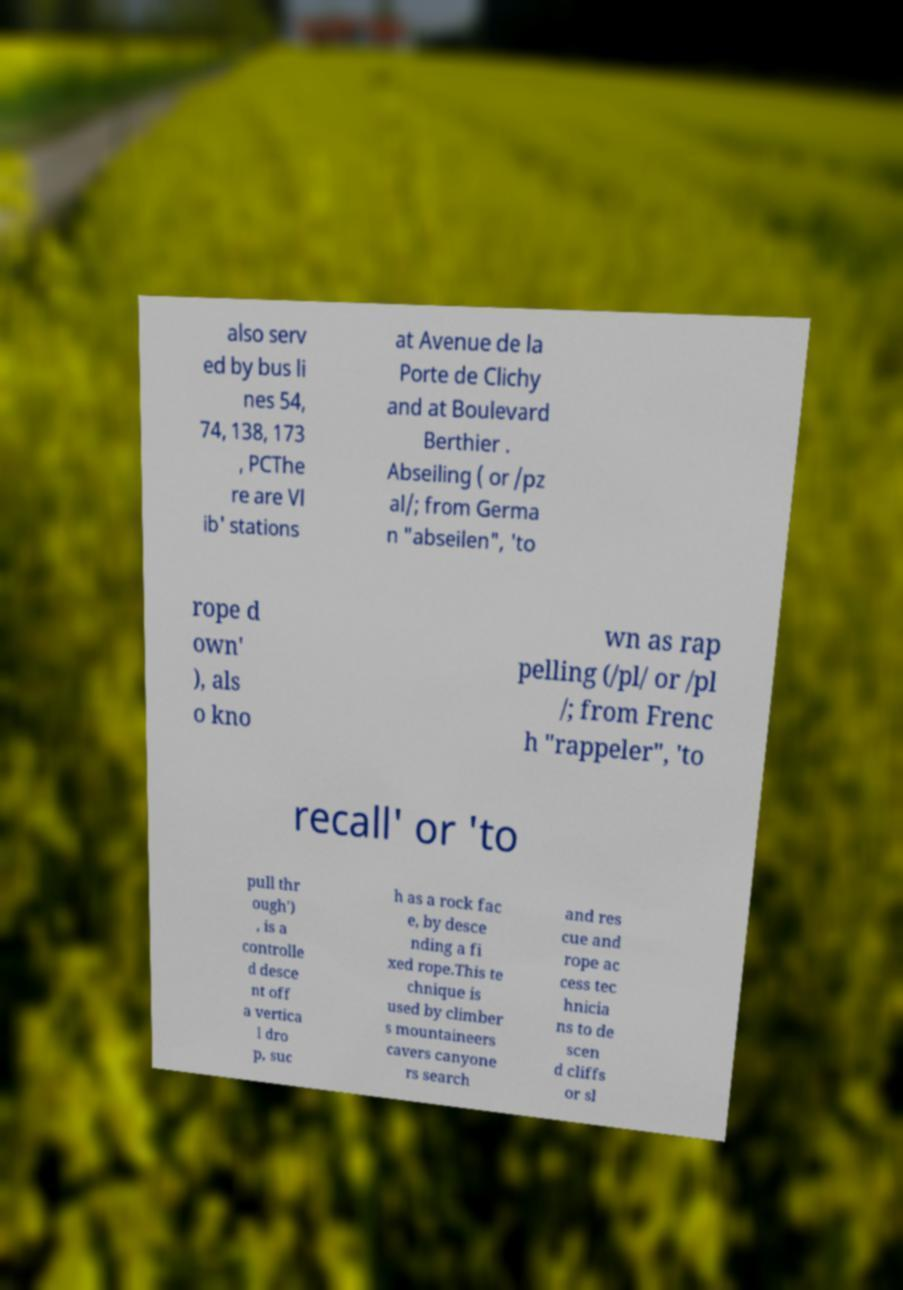Can you accurately transcribe the text from the provided image for me? also serv ed by bus li nes 54, 74, 138, 173 , PCThe re are Vl ib' stations at Avenue de la Porte de Clichy and at Boulevard Berthier . Abseiling ( or /pz al/; from Germa n "abseilen", 'to rope d own' ), als o kno wn as rap pelling (/pl/ or /pl /; from Frenc h "rappeler", 'to recall' or 'to pull thr ough') , is a controlle d desce nt off a vertica l dro p, suc h as a rock fac e, by desce nding a fi xed rope.This te chnique is used by climber s mountaineers cavers canyone rs search and res cue and rope ac cess tec hnicia ns to de scen d cliffs or sl 